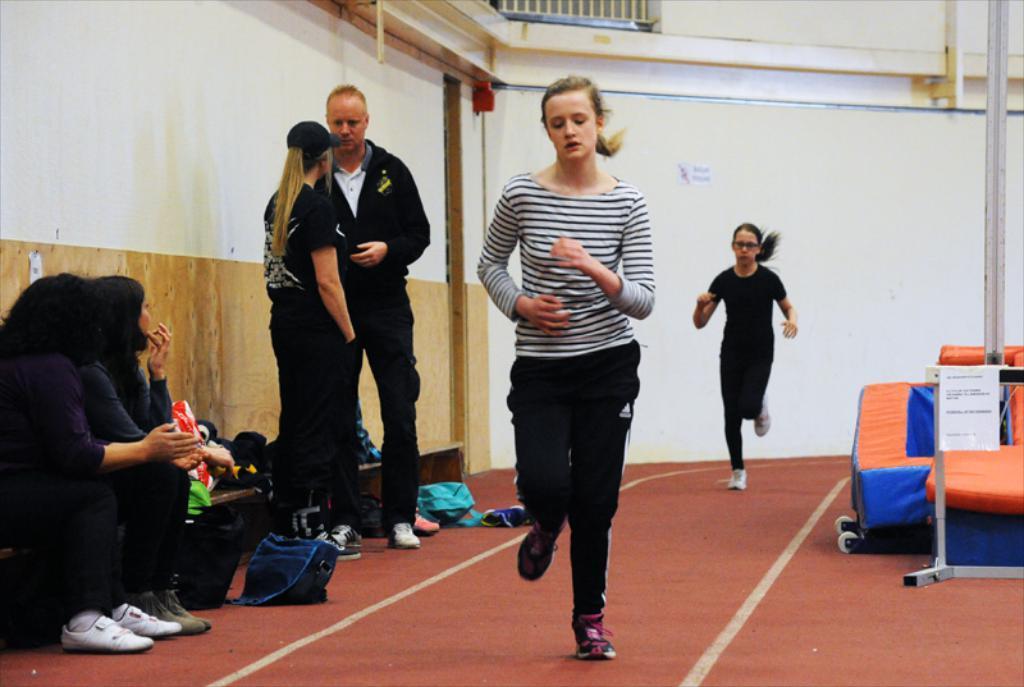Could you give a brief overview of what you see in this image? In this image we can see there are two persons running in the middle of this image. There are two persons standing on the right side to these persons and there are two persons sitting as we can see on the left side of this image. There is a wall in the background. There is one object kept on the right side of this image, and there are some objects kept on the bench as we can see on the left side of this image. 